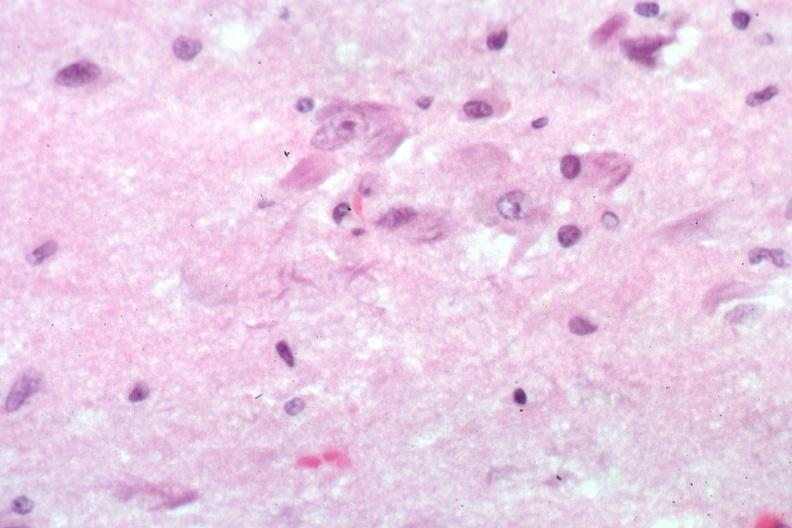s mesothelioma present?
Answer the question using a single word or phrase. No 